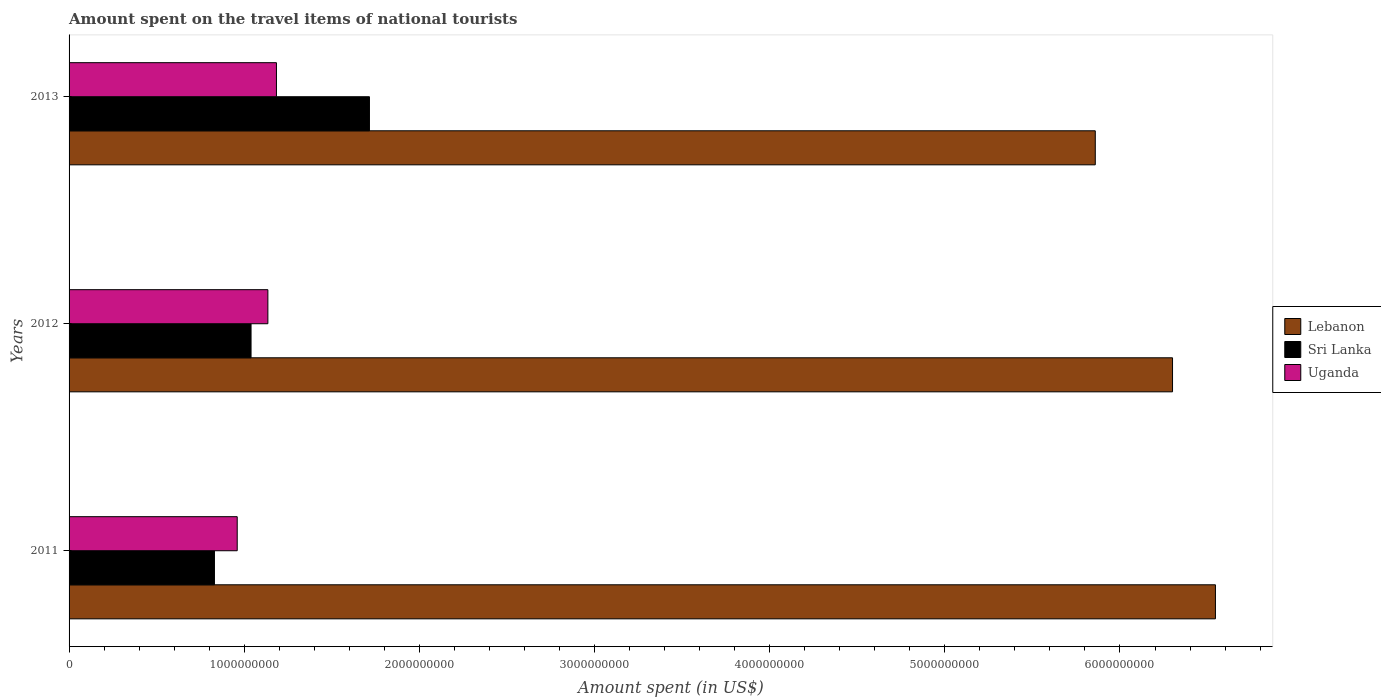Are the number of bars per tick equal to the number of legend labels?
Provide a succinct answer. Yes. How many bars are there on the 1st tick from the top?
Ensure brevity in your answer.  3. What is the amount spent on the travel items of national tourists in Uganda in 2012?
Ensure brevity in your answer.  1.14e+09. Across all years, what is the maximum amount spent on the travel items of national tourists in Uganda?
Your response must be concise. 1.18e+09. Across all years, what is the minimum amount spent on the travel items of national tourists in Uganda?
Ensure brevity in your answer.  9.60e+08. In which year was the amount spent on the travel items of national tourists in Uganda minimum?
Offer a very short reply. 2011. What is the total amount spent on the travel items of national tourists in Sri Lanka in the graph?
Ensure brevity in your answer.  3.58e+09. What is the difference between the amount spent on the travel items of national tourists in Uganda in 2012 and that in 2013?
Offer a terse response. -4.90e+07. What is the difference between the amount spent on the travel items of national tourists in Lebanon in 2011 and the amount spent on the travel items of national tourists in Uganda in 2012?
Offer a very short reply. 5.41e+09. What is the average amount spent on the travel items of national tourists in Sri Lanka per year?
Ensure brevity in your answer.  1.19e+09. In the year 2013, what is the difference between the amount spent on the travel items of national tourists in Uganda and amount spent on the travel items of national tourists in Lebanon?
Ensure brevity in your answer.  -4.68e+09. In how many years, is the amount spent on the travel items of national tourists in Uganda greater than 5400000000 US$?
Your answer should be very brief. 0. What is the ratio of the amount spent on the travel items of national tourists in Lebanon in 2012 to that in 2013?
Keep it short and to the point. 1.08. What is the difference between the highest and the second highest amount spent on the travel items of national tourists in Sri Lanka?
Your answer should be compact. 6.76e+08. What is the difference between the highest and the lowest amount spent on the travel items of national tourists in Sri Lanka?
Your response must be concise. 8.85e+08. Is the sum of the amount spent on the travel items of national tourists in Lebanon in 2012 and 2013 greater than the maximum amount spent on the travel items of national tourists in Sri Lanka across all years?
Your answer should be compact. Yes. What does the 3rd bar from the top in 2012 represents?
Your response must be concise. Lebanon. What does the 3rd bar from the bottom in 2011 represents?
Provide a succinct answer. Uganda. Is it the case that in every year, the sum of the amount spent on the travel items of national tourists in Lebanon and amount spent on the travel items of national tourists in Sri Lanka is greater than the amount spent on the travel items of national tourists in Uganda?
Your response must be concise. Yes. Are all the bars in the graph horizontal?
Ensure brevity in your answer.  Yes. How many years are there in the graph?
Provide a short and direct response. 3. Does the graph contain grids?
Provide a short and direct response. No. How are the legend labels stacked?
Offer a very short reply. Vertical. What is the title of the graph?
Your answer should be compact. Amount spent on the travel items of national tourists. Does "Middle East & North Africa (all income levels)" appear as one of the legend labels in the graph?
Your answer should be compact. No. What is the label or title of the X-axis?
Provide a short and direct response. Amount spent (in US$). What is the Amount spent (in US$) in Lebanon in 2011?
Provide a succinct answer. 6.54e+09. What is the Amount spent (in US$) of Sri Lanka in 2011?
Your answer should be compact. 8.30e+08. What is the Amount spent (in US$) of Uganda in 2011?
Ensure brevity in your answer.  9.60e+08. What is the Amount spent (in US$) in Lebanon in 2012?
Keep it short and to the point. 6.30e+09. What is the Amount spent (in US$) of Sri Lanka in 2012?
Your answer should be compact. 1.04e+09. What is the Amount spent (in US$) of Uganda in 2012?
Your response must be concise. 1.14e+09. What is the Amount spent (in US$) of Lebanon in 2013?
Your response must be concise. 5.86e+09. What is the Amount spent (in US$) in Sri Lanka in 2013?
Your answer should be compact. 1.72e+09. What is the Amount spent (in US$) in Uganda in 2013?
Provide a succinct answer. 1.18e+09. Across all years, what is the maximum Amount spent (in US$) in Lebanon?
Your answer should be compact. 6.54e+09. Across all years, what is the maximum Amount spent (in US$) of Sri Lanka?
Your answer should be compact. 1.72e+09. Across all years, what is the maximum Amount spent (in US$) in Uganda?
Keep it short and to the point. 1.18e+09. Across all years, what is the minimum Amount spent (in US$) of Lebanon?
Offer a terse response. 5.86e+09. Across all years, what is the minimum Amount spent (in US$) in Sri Lanka?
Offer a very short reply. 8.30e+08. Across all years, what is the minimum Amount spent (in US$) in Uganda?
Your answer should be compact. 9.60e+08. What is the total Amount spent (in US$) in Lebanon in the graph?
Make the answer very short. 1.87e+1. What is the total Amount spent (in US$) in Sri Lanka in the graph?
Make the answer very short. 3.58e+09. What is the total Amount spent (in US$) of Uganda in the graph?
Give a very brief answer. 3.28e+09. What is the difference between the Amount spent (in US$) in Lebanon in 2011 and that in 2012?
Keep it short and to the point. 2.45e+08. What is the difference between the Amount spent (in US$) of Sri Lanka in 2011 and that in 2012?
Offer a very short reply. -2.09e+08. What is the difference between the Amount spent (in US$) in Uganda in 2011 and that in 2012?
Your answer should be very brief. -1.75e+08. What is the difference between the Amount spent (in US$) of Lebanon in 2011 and that in 2013?
Offer a terse response. 6.86e+08. What is the difference between the Amount spent (in US$) of Sri Lanka in 2011 and that in 2013?
Give a very brief answer. -8.85e+08. What is the difference between the Amount spent (in US$) in Uganda in 2011 and that in 2013?
Your response must be concise. -2.24e+08. What is the difference between the Amount spent (in US$) of Lebanon in 2012 and that in 2013?
Give a very brief answer. 4.41e+08. What is the difference between the Amount spent (in US$) of Sri Lanka in 2012 and that in 2013?
Your answer should be very brief. -6.76e+08. What is the difference between the Amount spent (in US$) in Uganda in 2012 and that in 2013?
Provide a short and direct response. -4.90e+07. What is the difference between the Amount spent (in US$) in Lebanon in 2011 and the Amount spent (in US$) in Sri Lanka in 2012?
Your response must be concise. 5.51e+09. What is the difference between the Amount spent (in US$) of Lebanon in 2011 and the Amount spent (in US$) of Uganda in 2012?
Make the answer very short. 5.41e+09. What is the difference between the Amount spent (in US$) in Sri Lanka in 2011 and the Amount spent (in US$) in Uganda in 2012?
Make the answer very short. -3.05e+08. What is the difference between the Amount spent (in US$) in Lebanon in 2011 and the Amount spent (in US$) in Sri Lanka in 2013?
Your response must be concise. 4.83e+09. What is the difference between the Amount spent (in US$) of Lebanon in 2011 and the Amount spent (in US$) of Uganda in 2013?
Ensure brevity in your answer.  5.36e+09. What is the difference between the Amount spent (in US$) in Sri Lanka in 2011 and the Amount spent (in US$) in Uganda in 2013?
Your answer should be compact. -3.54e+08. What is the difference between the Amount spent (in US$) of Lebanon in 2012 and the Amount spent (in US$) of Sri Lanka in 2013?
Provide a short and direct response. 4.58e+09. What is the difference between the Amount spent (in US$) in Lebanon in 2012 and the Amount spent (in US$) in Uganda in 2013?
Provide a short and direct response. 5.12e+09. What is the difference between the Amount spent (in US$) in Sri Lanka in 2012 and the Amount spent (in US$) in Uganda in 2013?
Ensure brevity in your answer.  -1.45e+08. What is the average Amount spent (in US$) of Lebanon per year?
Give a very brief answer. 6.23e+09. What is the average Amount spent (in US$) in Sri Lanka per year?
Your response must be concise. 1.19e+09. What is the average Amount spent (in US$) in Uganda per year?
Offer a terse response. 1.09e+09. In the year 2011, what is the difference between the Amount spent (in US$) in Lebanon and Amount spent (in US$) in Sri Lanka?
Your answer should be very brief. 5.72e+09. In the year 2011, what is the difference between the Amount spent (in US$) of Lebanon and Amount spent (in US$) of Uganda?
Your response must be concise. 5.58e+09. In the year 2011, what is the difference between the Amount spent (in US$) of Sri Lanka and Amount spent (in US$) of Uganda?
Offer a terse response. -1.30e+08. In the year 2012, what is the difference between the Amount spent (in US$) of Lebanon and Amount spent (in US$) of Sri Lanka?
Keep it short and to the point. 5.26e+09. In the year 2012, what is the difference between the Amount spent (in US$) of Lebanon and Amount spent (in US$) of Uganda?
Make the answer very short. 5.16e+09. In the year 2012, what is the difference between the Amount spent (in US$) of Sri Lanka and Amount spent (in US$) of Uganda?
Your answer should be compact. -9.60e+07. In the year 2013, what is the difference between the Amount spent (in US$) in Lebanon and Amount spent (in US$) in Sri Lanka?
Make the answer very short. 4.14e+09. In the year 2013, what is the difference between the Amount spent (in US$) of Lebanon and Amount spent (in US$) of Uganda?
Give a very brief answer. 4.68e+09. In the year 2013, what is the difference between the Amount spent (in US$) in Sri Lanka and Amount spent (in US$) in Uganda?
Give a very brief answer. 5.31e+08. What is the ratio of the Amount spent (in US$) of Lebanon in 2011 to that in 2012?
Your answer should be compact. 1.04. What is the ratio of the Amount spent (in US$) in Sri Lanka in 2011 to that in 2012?
Keep it short and to the point. 0.8. What is the ratio of the Amount spent (in US$) of Uganda in 2011 to that in 2012?
Offer a very short reply. 0.85. What is the ratio of the Amount spent (in US$) of Lebanon in 2011 to that in 2013?
Provide a short and direct response. 1.12. What is the ratio of the Amount spent (in US$) in Sri Lanka in 2011 to that in 2013?
Provide a succinct answer. 0.48. What is the ratio of the Amount spent (in US$) in Uganda in 2011 to that in 2013?
Ensure brevity in your answer.  0.81. What is the ratio of the Amount spent (in US$) of Lebanon in 2012 to that in 2013?
Your response must be concise. 1.08. What is the ratio of the Amount spent (in US$) in Sri Lanka in 2012 to that in 2013?
Keep it short and to the point. 0.61. What is the ratio of the Amount spent (in US$) of Uganda in 2012 to that in 2013?
Provide a succinct answer. 0.96. What is the difference between the highest and the second highest Amount spent (in US$) in Lebanon?
Give a very brief answer. 2.45e+08. What is the difference between the highest and the second highest Amount spent (in US$) of Sri Lanka?
Your response must be concise. 6.76e+08. What is the difference between the highest and the second highest Amount spent (in US$) of Uganda?
Keep it short and to the point. 4.90e+07. What is the difference between the highest and the lowest Amount spent (in US$) in Lebanon?
Provide a short and direct response. 6.86e+08. What is the difference between the highest and the lowest Amount spent (in US$) of Sri Lanka?
Make the answer very short. 8.85e+08. What is the difference between the highest and the lowest Amount spent (in US$) in Uganda?
Offer a very short reply. 2.24e+08. 